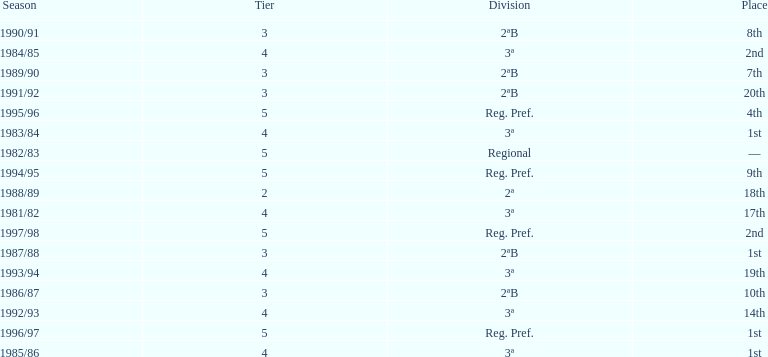How many times total did they finish first 4. 